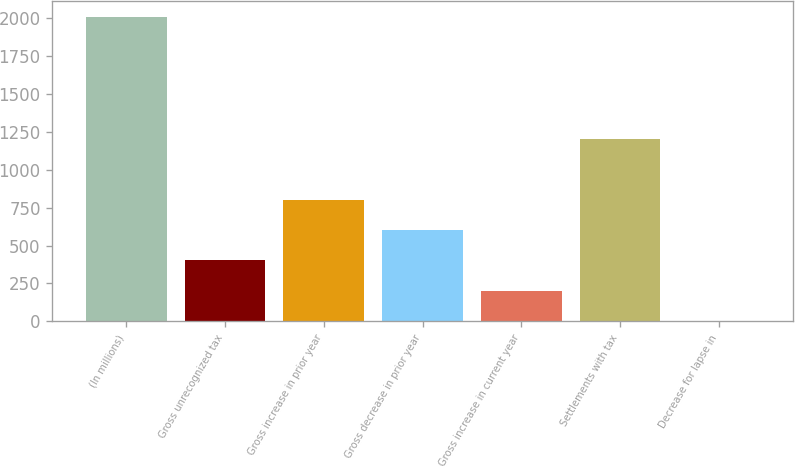<chart> <loc_0><loc_0><loc_500><loc_500><bar_chart><fcel>(In millions)<fcel>Gross unrecognized tax<fcel>Gross increase in prior year<fcel>Gross decrease in prior year<fcel>Gross increase in current year<fcel>Settlements with tax<fcel>Decrease for lapse in<nl><fcel>2008<fcel>401.76<fcel>803.32<fcel>602.54<fcel>200.98<fcel>1204.88<fcel>0.2<nl></chart> 